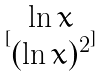<formula> <loc_0><loc_0><loc_500><loc_500>[ \begin{matrix} \ln x \\ ( \ln x ) ^ { 2 } \end{matrix} ]</formula> 